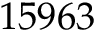<formula> <loc_0><loc_0><loc_500><loc_500>1 5 9 6 3</formula> 